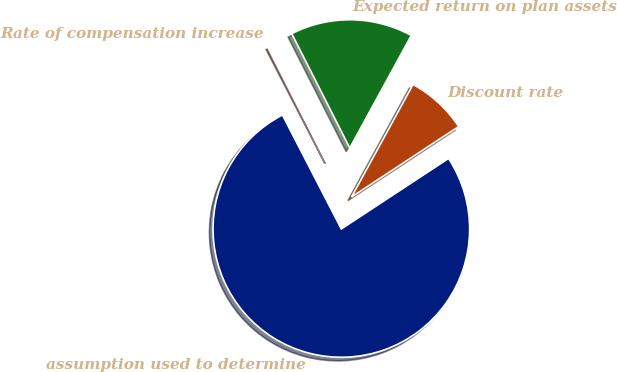Convert chart. <chart><loc_0><loc_0><loc_500><loc_500><pie_chart><fcel>assumption used to determine<fcel>Discount rate<fcel>Expected return on plan assets<fcel>Rate of compensation increase<nl><fcel>76.67%<fcel>7.78%<fcel>15.43%<fcel>0.12%<nl></chart> 